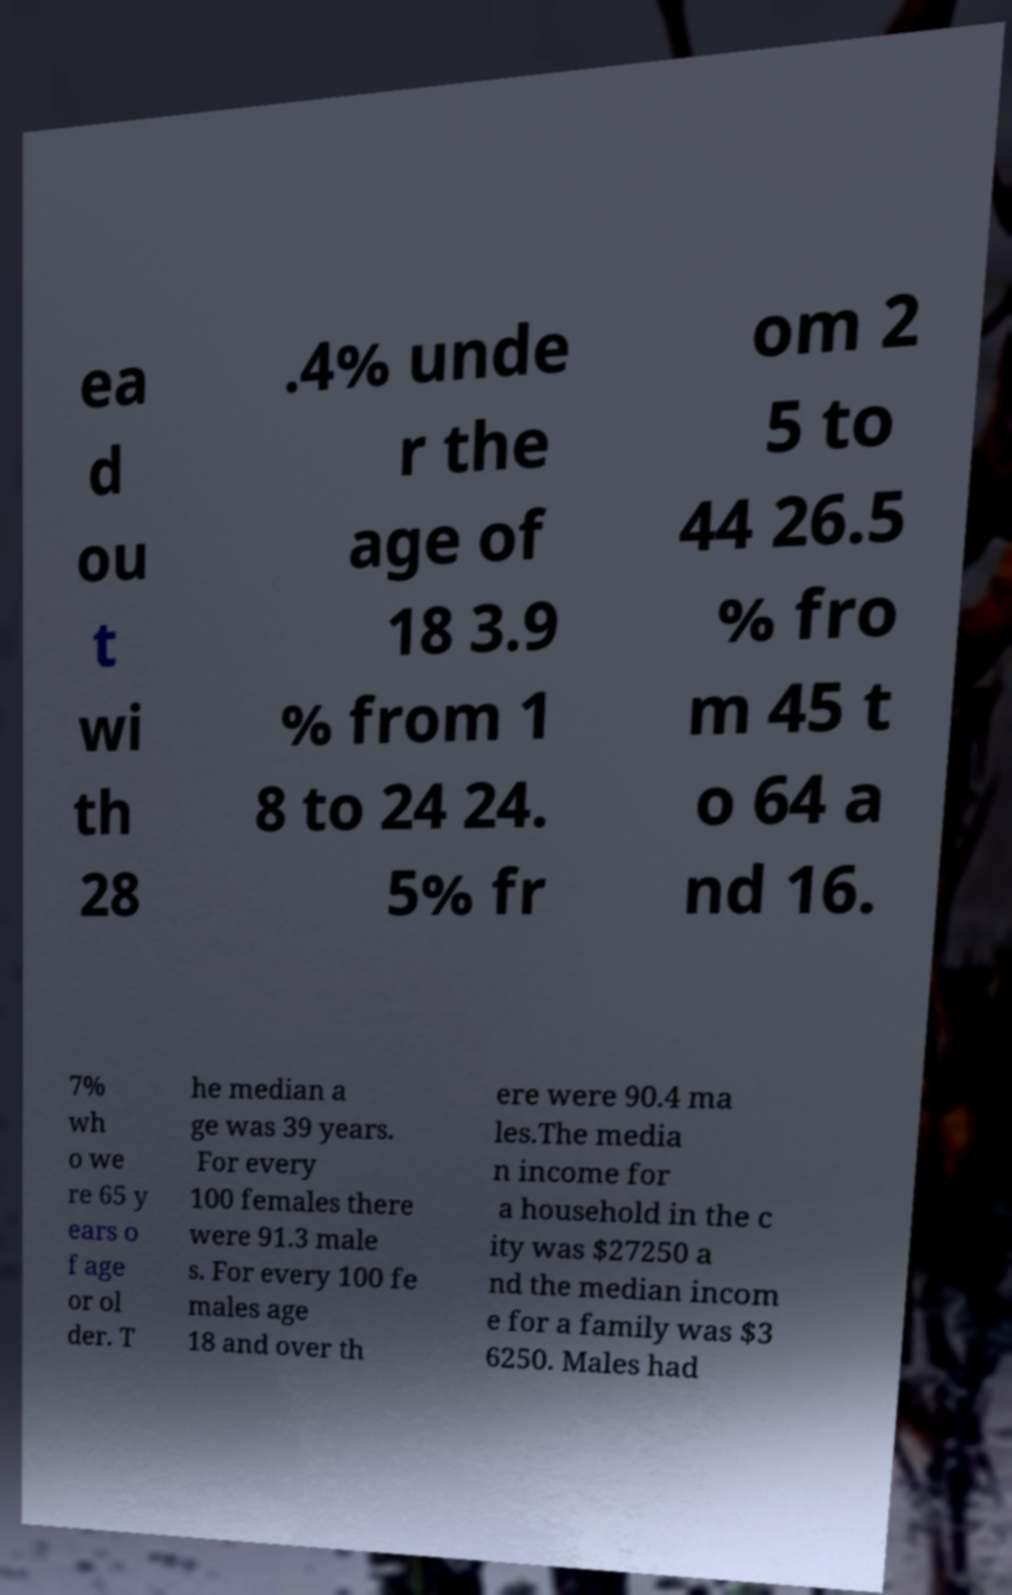Could you extract and type out the text from this image? ea d ou t wi th 28 .4% unde r the age of 18 3.9 % from 1 8 to 24 24. 5% fr om 2 5 to 44 26.5 % fro m 45 t o 64 a nd 16. 7% wh o we re 65 y ears o f age or ol der. T he median a ge was 39 years. For every 100 females there were 91.3 male s. For every 100 fe males age 18 and over th ere were 90.4 ma les.The media n income for a household in the c ity was $27250 a nd the median incom e for a family was $3 6250. Males had 